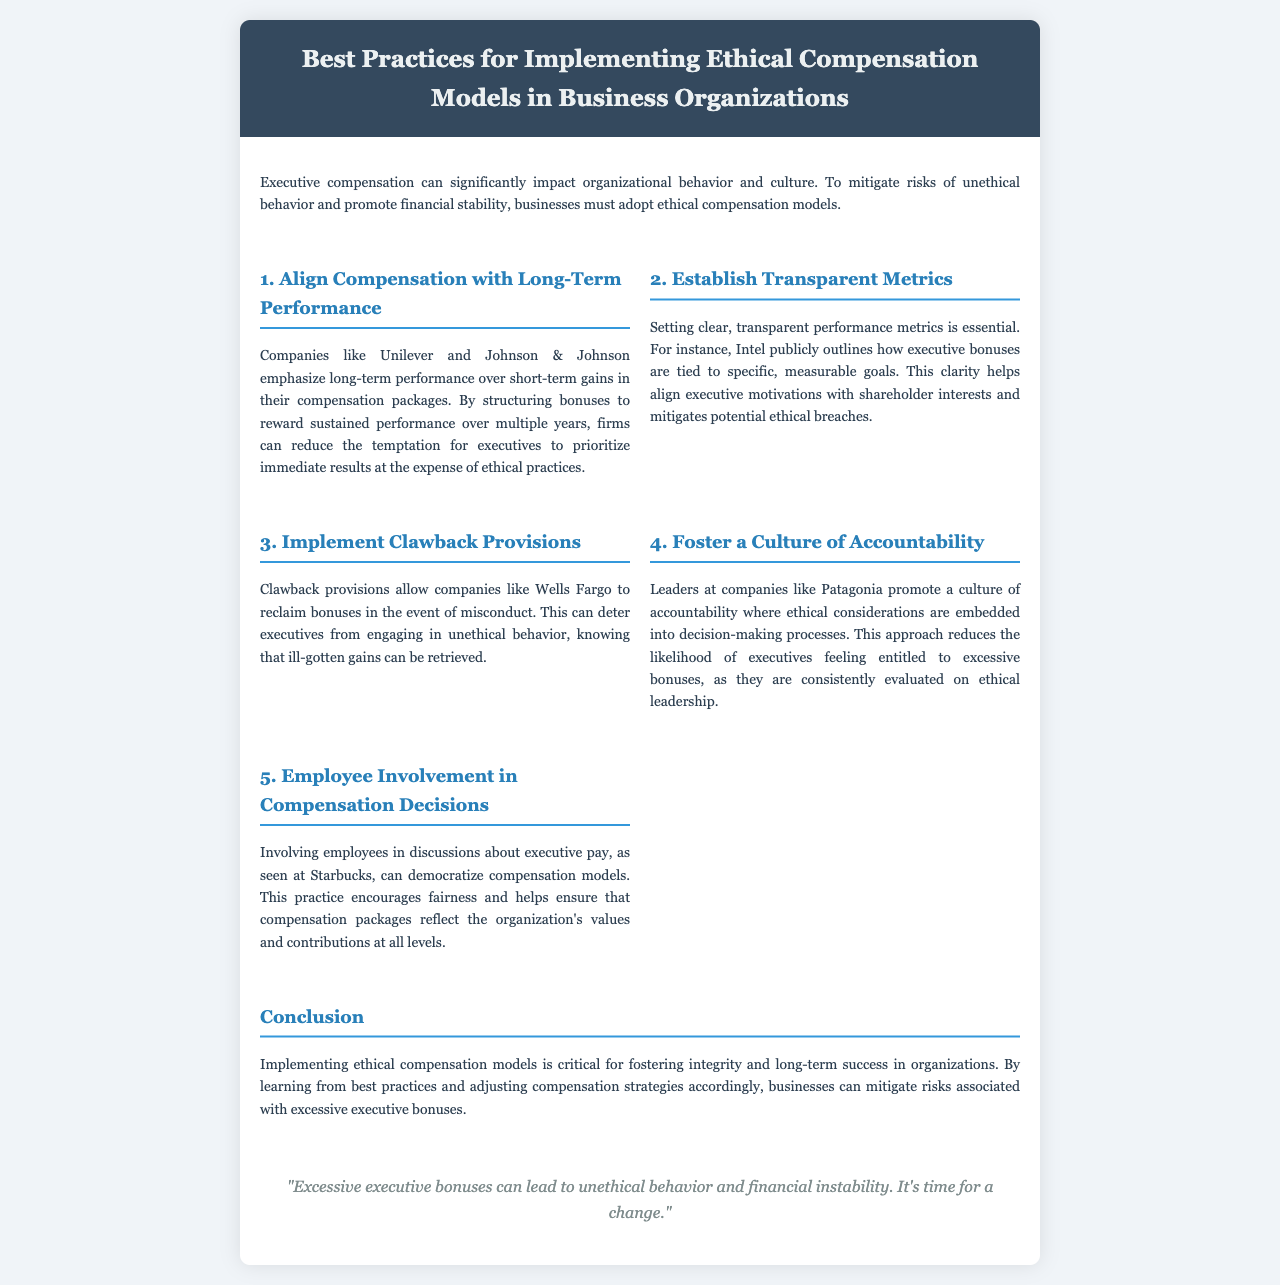What is the title of the brochure? The title of the brochure is located at the header section.
Answer: Best Practices for Implementing Ethical Compensation Models in Business Organizations What company is mentioned for implementing clawback provisions? The company using clawback provisions as an example is stated in the section discussing this practice.
Answer: Wells Fargo Which company emphasizes long-term performance in compensation packages? The document mentions specific companies that focus on long-term performance, found in the first section.
Answer: Unilever and Johnson & Johnson What does the quote in the brochure state about executive bonuses? The quote can be found at the bottom of the brochure and reflects a key insight.
Answer: "Excessive executive bonuses can lead to unethical behavior and financial instability. It's time for a change." How many best practices are outlined in the document? The total number of best practices is mentioned in the main content sections.
Answer: Five 